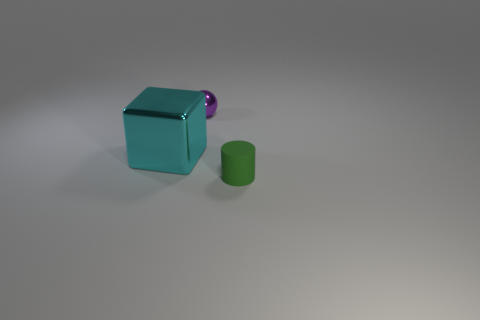Add 3 blocks. How many objects exist? 6 Subtract all spheres. How many objects are left? 2 Add 3 cyan metal blocks. How many cyan metal blocks are left? 4 Add 3 big blue shiny things. How many big blue shiny things exist? 3 Subtract 1 purple balls. How many objects are left? 2 Subtract all purple shiny balls. Subtract all large cyan cubes. How many objects are left? 1 